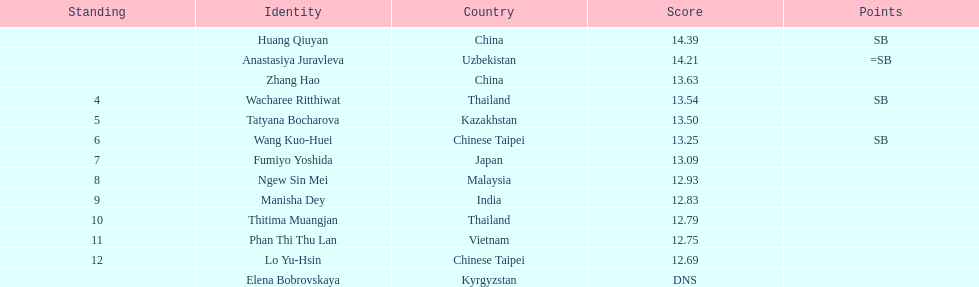How long was manisha dey's jump? 12.83. Would you be able to parse every entry in this table? {'header': ['Standing', 'Identity', 'Country', 'Score', 'Points'], 'rows': [['', 'Huang Qiuyan', 'China', '14.39', 'SB'], ['', 'Anastasiya Juravleva', 'Uzbekistan', '14.21', '=SB'], ['', 'Zhang Hao', 'China', '13.63', ''], ['4', 'Wacharee Ritthiwat', 'Thailand', '13.54', 'SB'], ['5', 'Tatyana Bocharova', 'Kazakhstan', '13.50', ''], ['6', 'Wang Kuo-Huei', 'Chinese Taipei', '13.25', 'SB'], ['7', 'Fumiyo Yoshida', 'Japan', '13.09', ''], ['8', 'Ngew Sin Mei', 'Malaysia', '12.93', ''], ['9', 'Manisha Dey', 'India', '12.83', ''], ['10', 'Thitima Muangjan', 'Thailand', '12.79', ''], ['11', 'Phan Thi Thu Lan', 'Vietnam', '12.75', ''], ['12', 'Lo Yu-Hsin', 'Chinese Taipei', '12.69', ''], ['', 'Elena Bobrovskaya', 'Kyrgyzstan', 'DNS', '']]} 